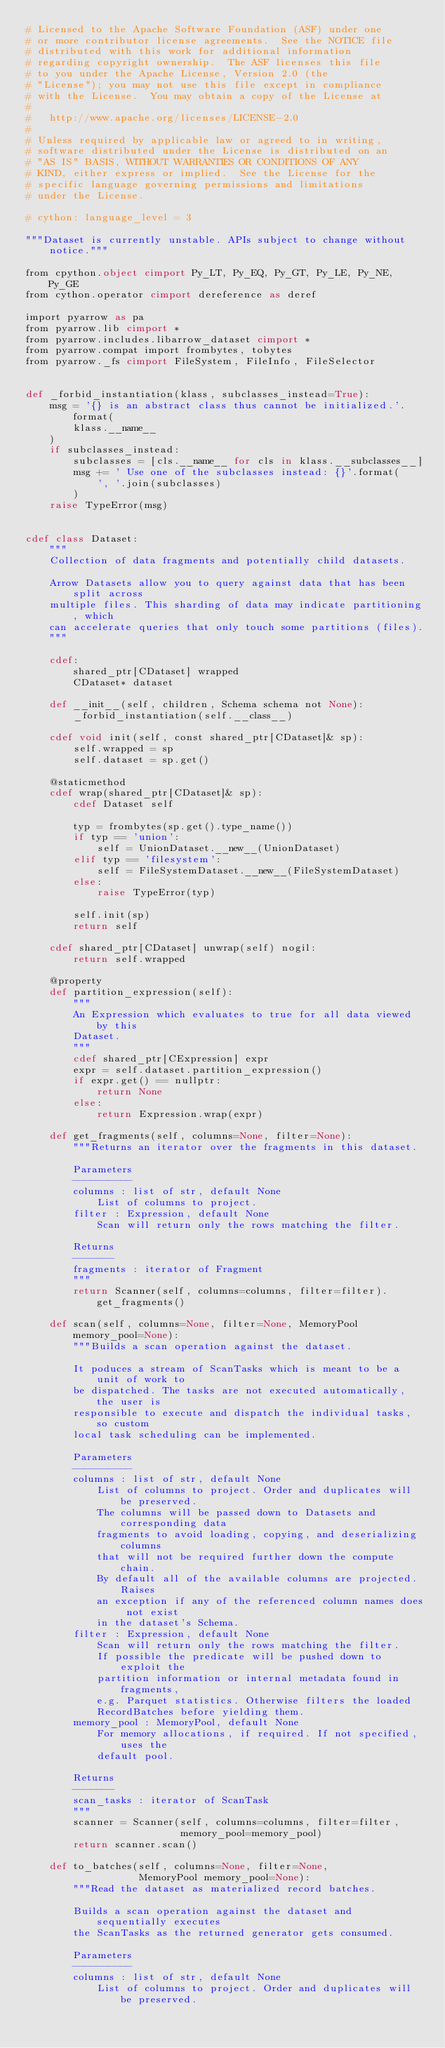<code> <loc_0><loc_0><loc_500><loc_500><_Cython_># Licensed to the Apache Software Foundation (ASF) under one
# or more contributor license agreements.  See the NOTICE file
# distributed with this work for additional information
# regarding copyright ownership.  The ASF licenses this file
# to you under the Apache License, Version 2.0 (the
# "License"); you may not use this file except in compliance
# with the License.  You may obtain a copy of the License at
#
#   http://www.apache.org/licenses/LICENSE-2.0
#
# Unless required by applicable law or agreed to in writing,
# software distributed under the License is distributed on an
# "AS IS" BASIS, WITHOUT WARRANTIES OR CONDITIONS OF ANY
# KIND, either express or implied.  See the License for the
# specific language governing permissions and limitations
# under the License.

# cython: language_level = 3

"""Dataset is currently unstable. APIs subject to change without notice."""

from cpython.object cimport Py_LT, Py_EQ, Py_GT, Py_LE, Py_NE, Py_GE
from cython.operator cimport dereference as deref

import pyarrow as pa
from pyarrow.lib cimport *
from pyarrow.includes.libarrow_dataset cimport *
from pyarrow.compat import frombytes, tobytes
from pyarrow._fs cimport FileSystem, FileInfo, FileSelector


def _forbid_instantiation(klass, subclasses_instead=True):
    msg = '{} is an abstract class thus cannot be initialized.'.format(
        klass.__name__
    )
    if subclasses_instead:
        subclasses = [cls.__name__ for cls in klass.__subclasses__]
        msg += ' Use one of the subclasses instead: {}'.format(
            ', '.join(subclasses)
        )
    raise TypeError(msg)


cdef class Dataset:
    """
    Collection of data fragments and potentially child datasets.

    Arrow Datasets allow you to query against data that has been split across
    multiple files. This sharding of data may indicate partitioning, which
    can accelerate queries that only touch some partitions (files).
    """

    cdef:
        shared_ptr[CDataset] wrapped
        CDataset* dataset

    def __init__(self, children, Schema schema not None):
        _forbid_instantiation(self.__class__)

    cdef void init(self, const shared_ptr[CDataset]& sp):
        self.wrapped = sp
        self.dataset = sp.get()

    @staticmethod
    cdef wrap(shared_ptr[CDataset]& sp):
        cdef Dataset self

        typ = frombytes(sp.get().type_name())
        if typ == 'union':
            self = UnionDataset.__new__(UnionDataset)
        elif typ == 'filesystem':
            self = FileSystemDataset.__new__(FileSystemDataset)
        else:
            raise TypeError(typ)

        self.init(sp)
        return self

    cdef shared_ptr[CDataset] unwrap(self) nogil:
        return self.wrapped

    @property
    def partition_expression(self):
        """
        An Expression which evaluates to true for all data viewed by this
        Dataset.
        """
        cdef shared_ptr[CExpression] expr
        expr = self.dataset.partition_expression()
        if expr.get() == nullptr:
            return None
        else:
            return Expression.wrap(expr)

    def get_fragments(self, columns=None, filter=None):
        """Returns an iterator over the fragments in this dataset.

        Parameters
        ----------
        columns : list of str, default None
            List of columns to project.
        filter : Expression, default None
            Scan will return only the rows matching the filter.

        Returns
        -------
        fragments : iterator of Fragment
        """
        return Scanner(self, columns=columns, filter=filter).get_fragments()

    def scan(self, columns=None, filter=None, MemoryPool memory_pool=None):
        """Builds a scan operation against the dataset.

        It poduces a stream of ScanTasks which is meant to be a unit of work to
        be dispatched. The tasks are not executed automatically, the user is
        responsible to execute and dispatch the individual tasks, so custom
        local task scheduling can be implemented.

        Parameters
        ----------
        columns : list of str, default None
            List of columns to project. Order and duplicates will be preserved.
            The columns will be passed down to Datasets and corresponding data
            fragments to avoid loading, copying, and deserializing columns
            that will not be required further down the compute chain.
            By default all of the available columns are projected. Raises
            an exception if any of the referenced column names does not exist
            in the dataset's Schema.
        filter : Expression, default None
            Scan will return only the rows matching the filter.
            If possible the predicate will be pushed down to exploit the
            partition information or internal metadata found in fragments,
            e.g. Parquet statistics. Otherwise filters the loaded
            RecordBatches before yielding them.
        memory_pool : MemoryPool, default None
            For memory allocations, if required. If not specified, uses the
            default pool.

        Returns
        -------
        scan_tasks : iterator of ScanTask
        """
        scanner = Scanner(self, columns=columns, filter=filter,
                          memory_pool=memory_pool)
        return scanner.scan()

    def to_batches(self, columns=None, filter=None,
                   MemoryPool memory_pool=None):
        """Read the dataset as materialized record batches.

        Builds a scan operation against the dataset and sequentially executes
        the ScanTasks as the returned generator gets consumed.

        Parameters
        ----------
        columns : list of str, default None
            List of columns to project. Order and duplicates will be preserved.</code> 